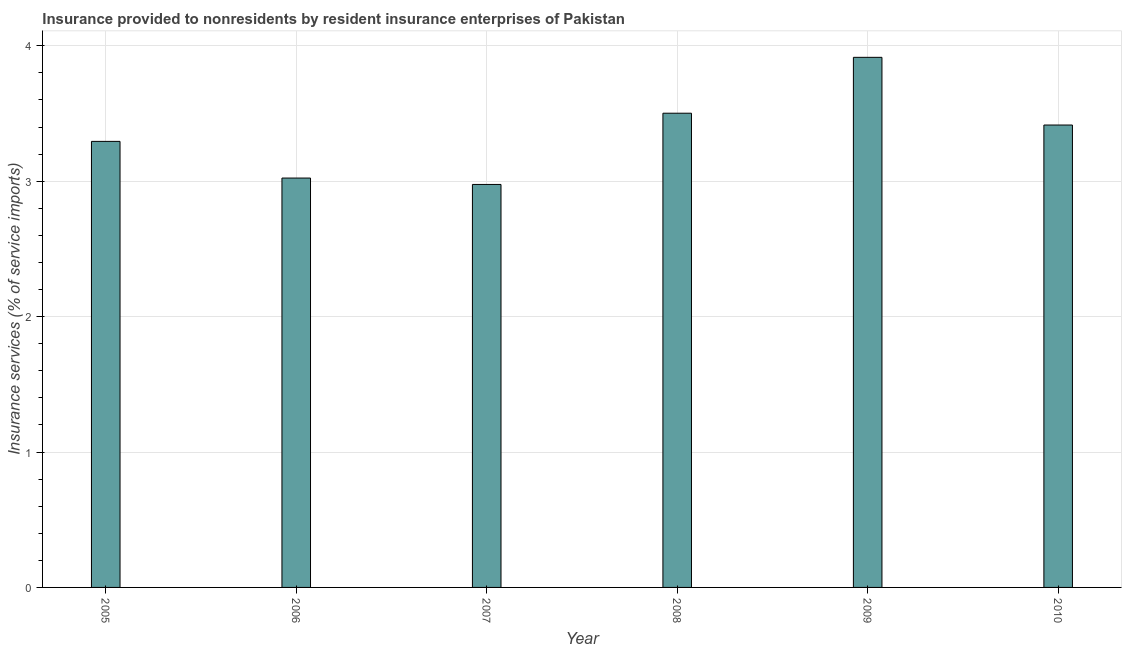Does the graph contain any zero values?
Provide a succinct answer. No. Does the graph contain grids?
Your answer should be very brief. Yes. What is the title of the graph?
Your answer should be very brief. Insurance provided to nonresidents by resident insurance enterprises of Pakistan. What is the label or title of the Y-axis?
Your answer should be compact. Insurance services (% of service imports). What is the insurance and financial services in 2009?
Keep it short and to the point. 3.91. Across all years, what is the maximum insurance and financial services?
Offer a terse response. 3.91. Across all years, what is the minimum insurance and financial services?
Offer a terse response. 2.98. In which year was the insurance and financial services minimum?
Your answer should be very brief. 2007. What is the sum of the insurance and financial services?
Keep it short and to the point. 20.12. What is the difference between the insurance and financial services in 2006 and 2010?
Keep it short and to the point. -0.39. What is the average insurance and financial services per year?
Give a very brief answer. 3.35. What is the median insurance and financial services?
Offer a terse response. 3.35. In how many years, is the insurance and financial services greater than 0.4 %?
Your answer should be very brief. 6. Do a majority of the years between 2009 and 2007 (inclusive) have insurance and financial services greater than 2.2 %?
Keep it short and to the point. Yes. What is the ratio of the insurance and financial services in 2005 to that in 2006?
Offer a terse response. 1.09. What is the difference between the highest and the second highest insurance and financial services?
Your answer should be very brief. 0.41. Is the sum of the insurance and financial services in 2007 and 2008 greater than the maximum insurance and financial services across all years?
Ensure brevity in your answer.  Yes. What is the difference between the highest and the lowest insurance and financial services?
Your response must be concise. 0.94. Are all the bars in the graph horizontal?
Your answer should be compact. No. How many years are there in the graph?
Provide a succinct answer. 6. What is the difference between two consecutive major ticks on the Y-axis?
Offer a terse response. 1. What is the Insurance services (% of service imports) of 2005?
Your response must be concise. 3.29. What is the Insurance services (% of service imports) in 2006?
Ensure brevity in your answer.  3.02. What is the Insurance services (% of service imports) of 2007?
Keep it short and to the point. 2.98. What is the Insurance services (% of service imports) of 2008?
Your answer should be compact. 3.5. What is the Insurance services (% of service imports) of 2009?
Give a very brief answer. 3.91. What is the Insurance services (% of service imports) in 2010?
Provide a succinct answer. 3.41. What is the difference between the Insurance services (% of service imports) in 2005 and 2006?
Offer a terse response. 0.27. What is the difference between the Insurance services (% of service imports) in 2005 and 2007?
Ensure brevity in your answer.  0.32. What is the difference between the Insurance services (% of service imports) in 2005 and 2008?
Your answer should be very brief. -0.21. What is the difference between the Insurance services (% of service imports) in 2005 and 2009?
Offer a terse response. -0.62. What is the difference between the Insurance services (% of service imports) in 2005 and 2010?
Offer a very short reply. -0.12. What is the difference between the Insurance services (% of service imports) in 2006 and 2007?
Keep it short and to the point. 0.05. What is the difference between the Insurance services (% of service imports) in 2006 and 2008?
Provide a succinct answer. -0.48. What is the difference between the Insurance services (% of service imports) in 2006 and 2009?
Keep it short and to the point. -0.89. What is the difference between the Insurance services (% of service imports) in 2006 and 2010?
Your response must be concise. -0.39. What is the difference between the Insurance services (% of service imports) in 2007 and 2008?
Your answer should be compact. -0.53. What is the difference between the Insurance services (% of service imports) in 2007 and 2009?
Make the answer very short. -0.94. What is the difference between the Insurance services (% of service imports) in 2007 and 2010?
Your response must be concise. -0.44. What is the difference between the Insurance services (% of service imports) in 2008 and 2009?
Provide a succinct answer. -0.41. What is the difference between the Insurance services (% of service imports) in 2008 and 2010?
Offer a very short reply. 0.09. What is the difference between the Insurance services (% of service imports) in 2009 and 2010?
Make the answer very short. 0.5. What is the ratio of the Insurance services (% of service imports) in 2005 to that in 2006?
Your response must be concise. 1.09. What is the ratio of the Insurance services (% of service imports) in 2005 to that in 2007?
Make the answer very short. 1.11. What is the ratio of the Insurance services (% of service imports) in 2005 to that in 2008?
Your answer should be very brief. 0.94. What is the ratio of the Insurance services (% of service imports) in 2005 to that in 2009?
Give a very brief answer. 0.84. What is the ratio of the Insurance services (% of service imports) in 2006 to that in 2008?
Your answer should be very brief. 0.86. What is the ratio of the Insurance services (% of service imports) in 2006 to that in 2009?
Make the answer very short. 0.77. What is the ratio of the Insurance services (% of service imports) in 2006 to that in 2010?
Provide a short and direct response. 0.89. What is the ratio of the Insurance services (% of service imports) in 2007 to that in 2009?
Your answer should be very brief. 0.76. What is the ratio of the Insurance services (% of service imports) in 2007 to that in 2010?
Your answer should be very brief. 0.87. What is the ratio of the Insurance services (% of service imports) in 2008 to that in 2009?
Your response must be concise. 0.9. What is the ratio of the Insurance services (% of service imports) in 2008 to that in 2010?
Give a very brief answer. 1.03. What is the ratio of the Insurance services (% of service imports) in 2009 to that in 2010?
Offer a terse response. 1.15. 